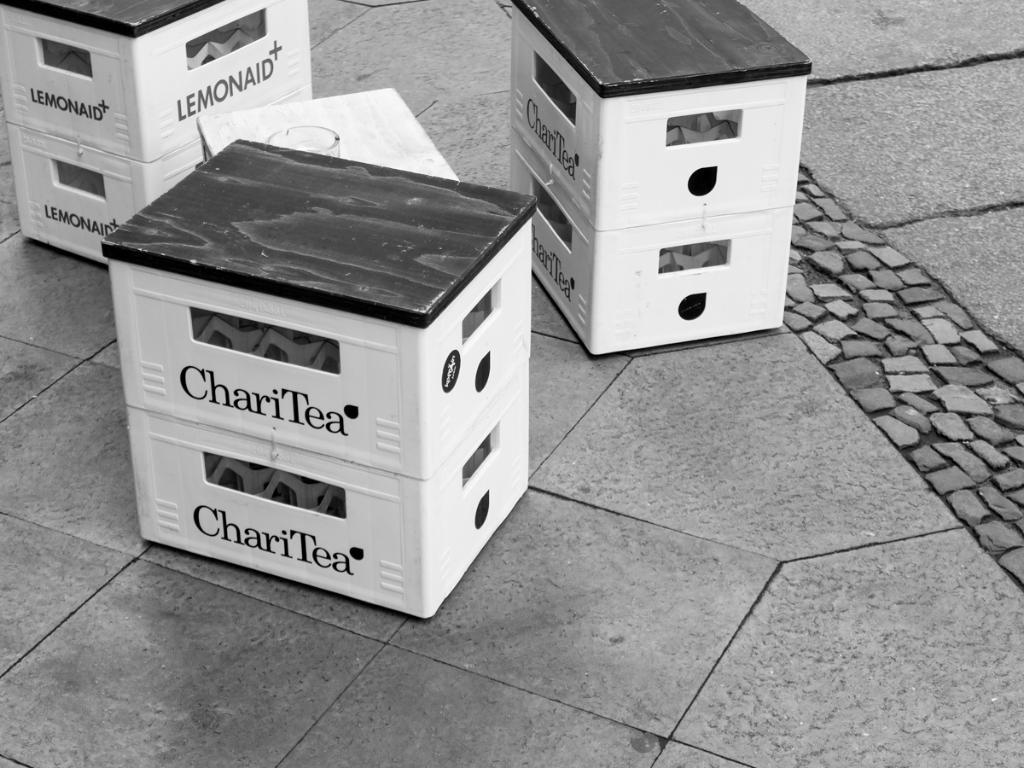What kind of tea brand is shown?
Make the answer very short. Charitea. Is the brand charitea?
Offer a very short reply. Yes. 